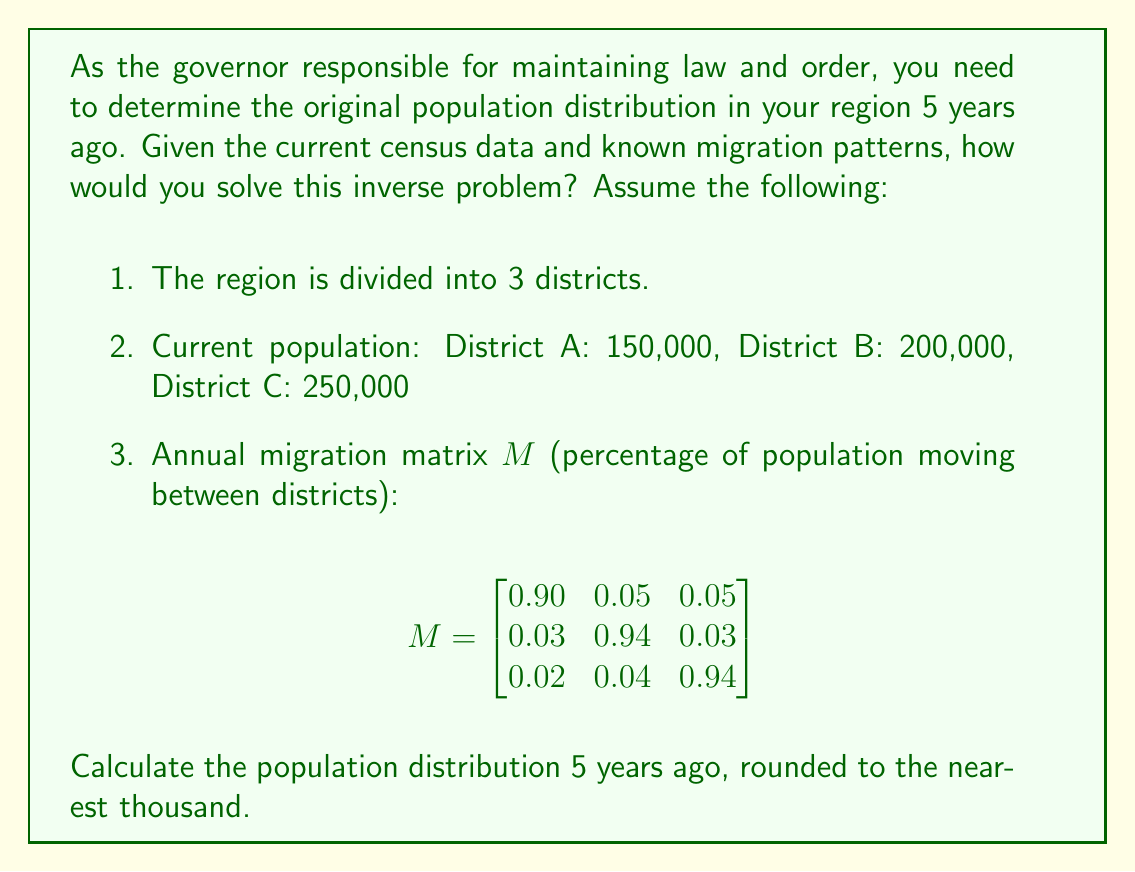Teach me how to tackle this problem. To solve this inverse problem, we need to work backwards from the current population distribution using the given migration matrix. Let's approach this step-by-step:

1) Let $P_t$ be the population vector at time $t$, where $t=0$ represents 5 years ago and $t=5$ represents the current year.

2) The current population vector is:
   $$P_5 = \begin{bmatrix} 150000 \\ 200000 \\ 250000 \end{bmatrix}$$

3) The relationship between population vectors in consecutive years is:
   $$P_{t+1} = M \cdot P_t$$

4) To go backwards in time, we need to use the inverse of the migration matrix:
   $$P_t = M^{-1} \cdot P_{t+1}$$

5) Calculate $M^{-1}$ (using a computer algebra system):
   $$M^{-1} \approx \begin{bmatrix}
   1.1161 & -0.0593 & -0.0568 \\
   -0.0356 & 1.0669 & -0.0313 \\
   -0.0236 & -0.0445 & 1.0681
   \end{bmatrix}$$

6) To go back 5 years, we need to apply this operation 5 times:
   $$P_0 = (M^{-1})^5 \cdot P_5$$

7) Calculate $(M^{-1})^5$ (using a computer algebra system):
   $$(M^{-1})^5 \approx \begin{bmatrix}
   1.7321 & -0.3645 & -0.3676 \\
   -0.2187 & 1.4114 & -0.1927 \\
   -0.1451 & -0.2337 & 1.3788
   \end{bmatrix}$$

8) Now, multiply this matrix by the current population vector:
   $$P_0 \approx \begin{bmatrix}
   1.7321 & -0.3645 & -0.3676 \\
   -0.2187 & 1.4114 & -0.1927 \\
   -0.1451 & -0.2337 & 1.3788
   \end{bmatrix} \cdot \begin{bmatrix} 150000 \\ 200000 \\ 250000 \end{bmatrix}$$

9) Performing this multiplication:
   $$P_0 \approx \begin{bmatrix} 121815 \\ 194260 \\ 283925 \end{bmatrix}$$

10) Rounding to the nearest thousand:
    $$P_0 \approx \begin{bmatrix} 122000 \\ 194000 \\ 284000 \end{bmatrix}$$

Therefore, the estimated population distribution 5 years ago was approximately 122,000 in District A, 194,000 in District B, and 284,000 in District C.
Answer: District A: 122,000; District B: 194,000; District C: 284,000 